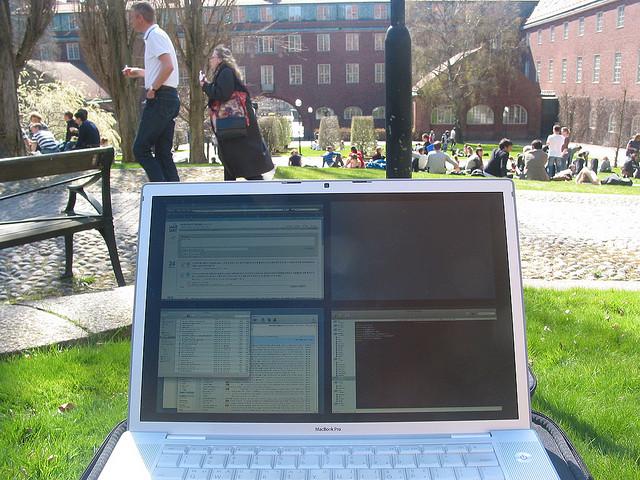Is the laptop turned off?
Give a very brief answer. No. Is it raining?
Concise answer only. No. How many benches are there?
Concise answer only. 1. 